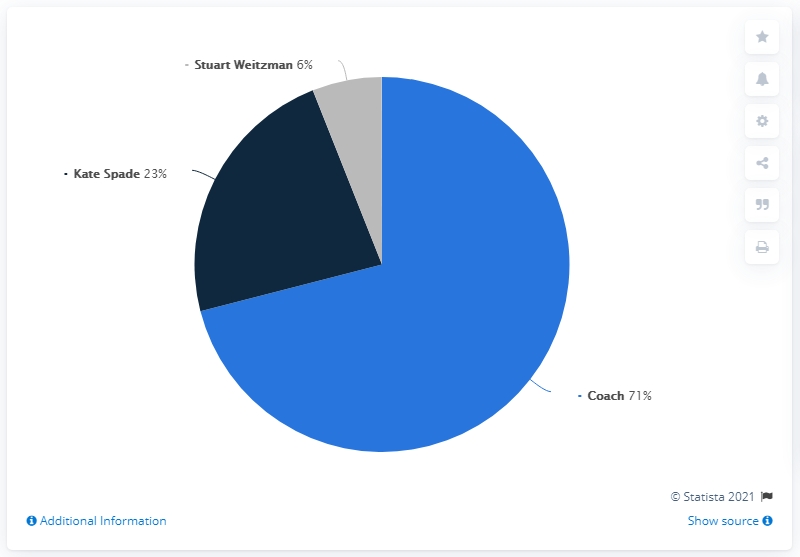Draw attention to some important aspects in this diagram. Coach has the highest share among the three. The ratio of coach to Stuart Weizmann is approximately 11.83333333... 